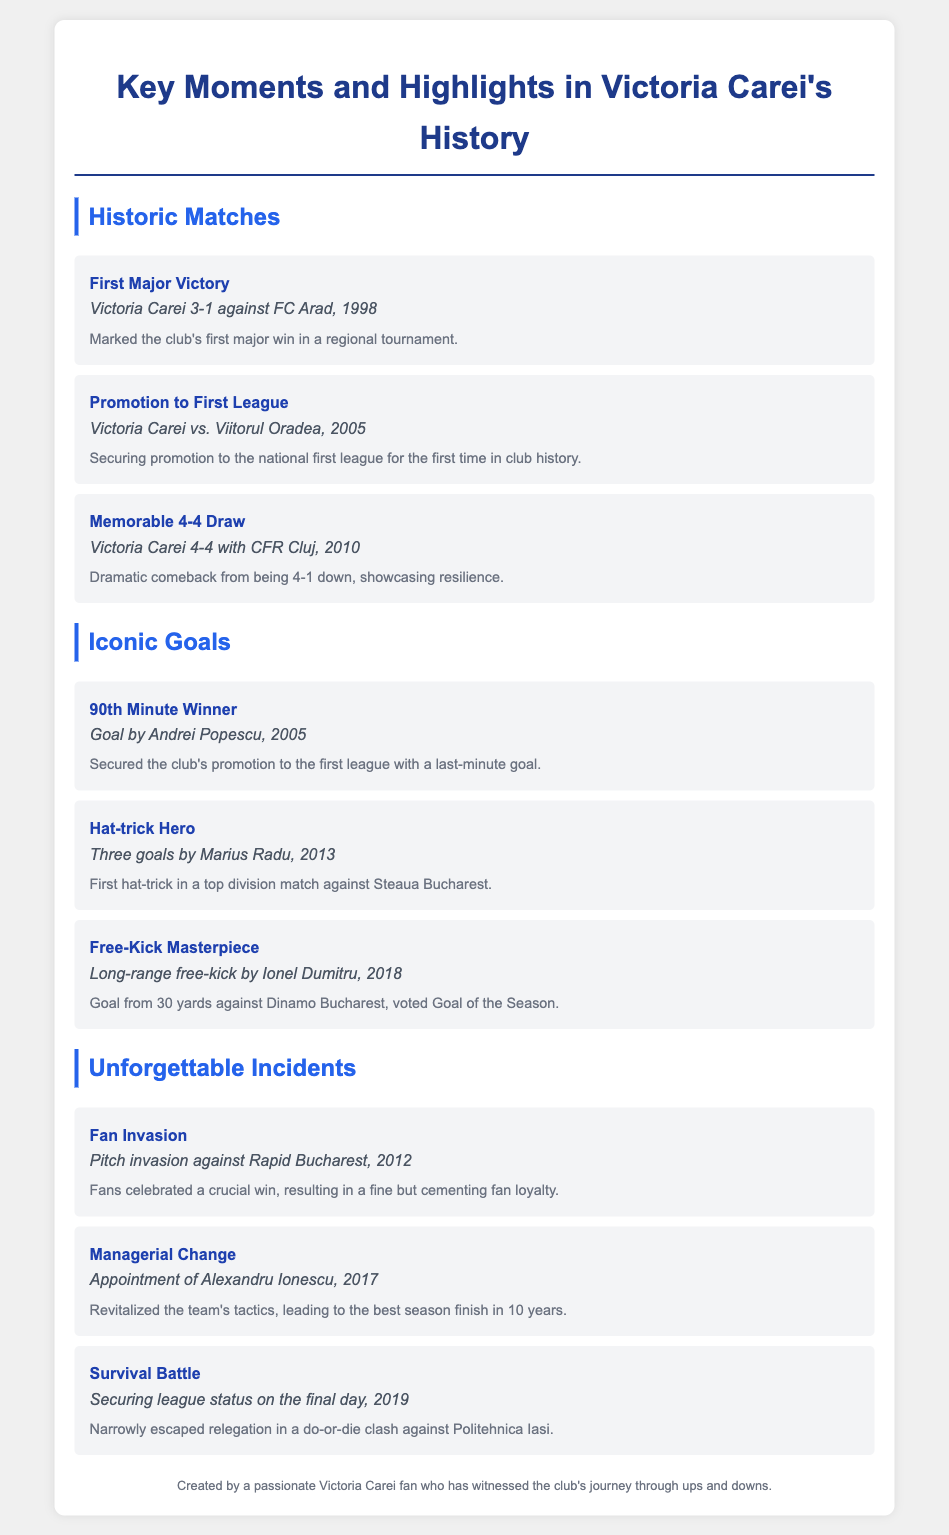What was Victoria Carei's first major victory? The first major victory for Victoria Carei was a match against FC Arad in 1998.
Answer: FC Arad When did Victoria Carei secure promotion to the national first league? The club secured promotion in 2005 against Viitorul Oradea.
Answer: 2005 Who scored the 90th-minute winner that secured promotion? The goal was scored by Andrei Popescu in 2005.
Answer: Andrei Popescu What significant incident happened during the match against Rapid Bucharest? Fans celebrated a crucial win leading to a pitch invasion in 2012.
Answer: Pitch invasion Which player achieved a hat-trick against Steaua Bucharest? Marius Radu scored a hat-trick in 2013.
Answer: Marius Radu What was the score during the memorable 4-4 draw with CFR Cluj? The match ended in a dramatic 4-4 draw in 2010.
Answer: 4-4 What event resulted in a managerial change in 2017? Alexandru Ionescu was appointed, revitalizing the team.
Answer: Appointment of Alexandru Ionescu In what year did Victoria Carei secure league status on the final day? The club secured its league status in 2019 against Politehnica Iasi.
Answer: 2019 